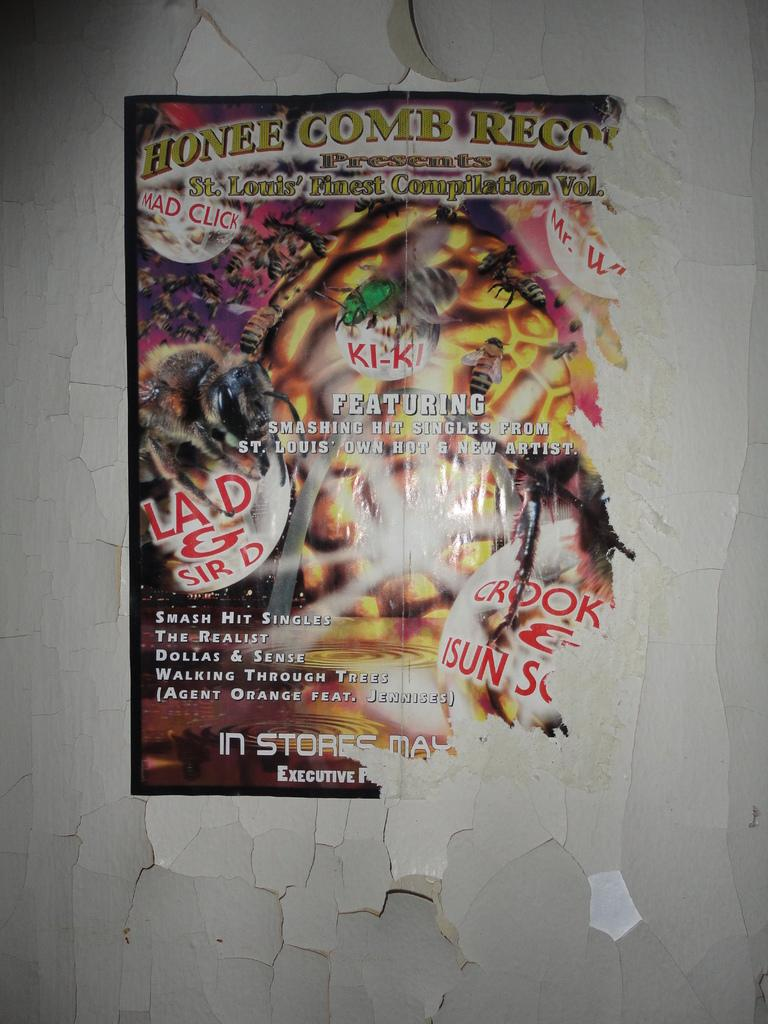<image>
Relay a brief, clear account of the picture shown. An advert for Honee Comb Regon featuring Ki-Ki, Lad & Sir D, and Mad click. 